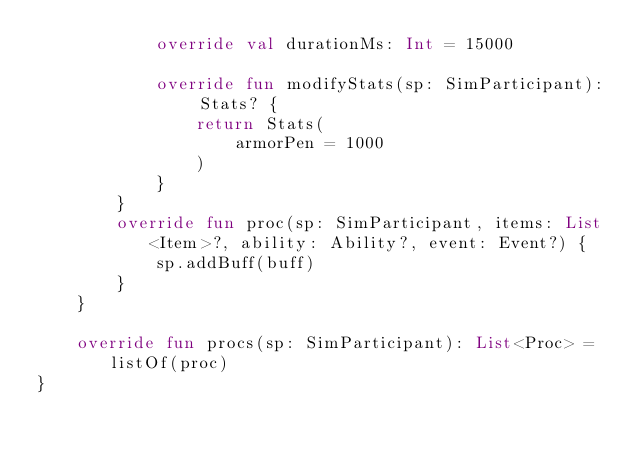<code> <loc_0><loc_0><loc_500><loc_500><_Kotlin_>            override val durationMs: Int = 15000

            override fun modifyStats(sp: SimParticipant): Stats? {
                return Stats(
                    armorPen = 1000
                )
            }
        }
        override fun proc(sp: SimParticipant, items: List<Item>?, ability: Ability?, event: Event?) {
            sp.addBuff(buff)
        }
    }

    override fun procs(sp: SimParticipant): List<Proc> = listOf(proc)
}
</code> 